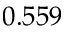Convert formula to latex. <formula><loc_0><loc_0><loc_500><loc_500>0 . 5 5 9</formula> 